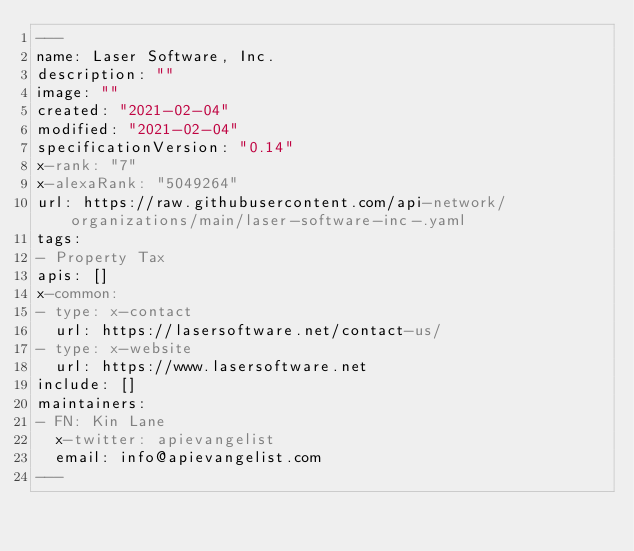Convert code to text. <code><loc_0><loc_0><loc_500><loc_500><_YAML_>---
name: Laser Software, Inc.
description: ""
image: ""
created: "2021-02-04"
modified: "2021-02-04"
specificationVersion: "0.14"
x-rank: "7"
x-alexaRank: "5049264"
url: https://raw.githubusercontent.com/api-network/organizations/main/laser-software-inc-.yaml
tags:
- Property Tax
apis: []
x-common:
- type: x-contact
  url: https://lasersoftware.net/contact-us/
- type: x-website
  url: https://www.lasersoftware.net
include: []
maintainers:
- FN: Kin Lane
  x-twitter: apievangelist
  email: info@apievangelist.com
---</code> 